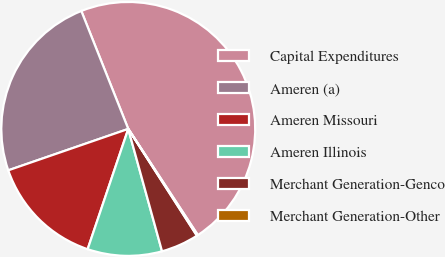Convert chart. <chart><loc_0><loc_0><loc_500><loc_500><pie_chart><fcel>Capital Expenditures<fcel>Ameren (a)<fcel>Ameren Missouri<fcel>Ameren Illinois<fcel>Merchant Generation-Genco<fcel>Merchant Generation-Other<nl><fcel>46.8%<fcel>24.26%<fcel>14.53%<fcel>9.47%<fcel>4.81%<fcel>0.14%<nl></chart> 